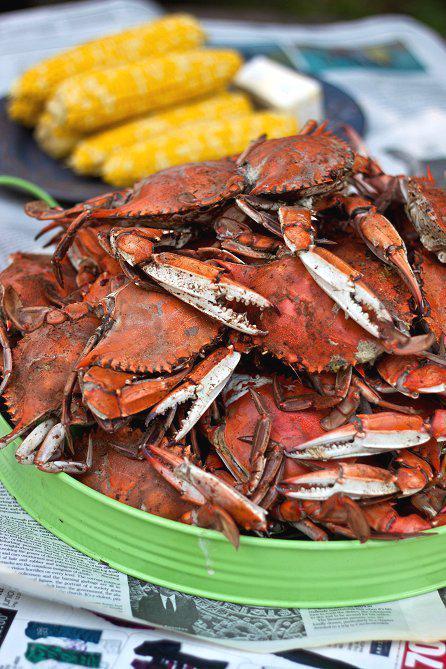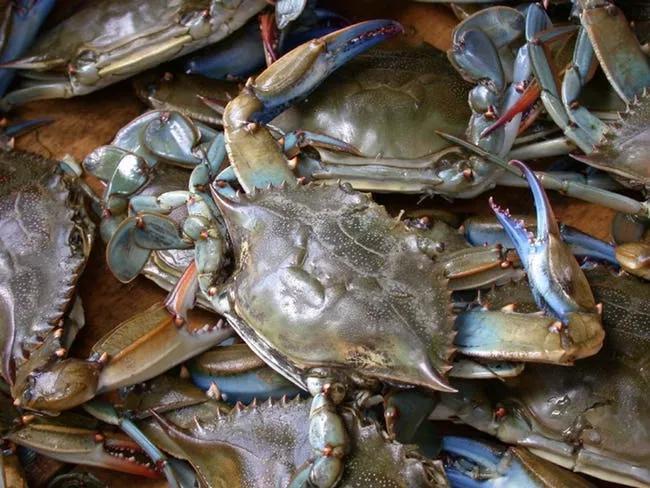The first image is the image on the left, the second image is the image on the right. Analyze the images presented: Is the assertion "Five or fewer crab bodies are visible." valid? Answer yes or no. No. The first image is the image on the left, the second image is the image on the right. Considering the images on both sides, is "In the right image there is a single crab facing the camera." valid? Answer yes or no. No. 